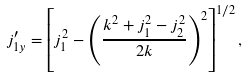<formula> <loc_0><loc_0><loc_500><loc_500>j ^ { \prime } _ { 1 y } = \left [ j _ { 1 } ^ { 2 } - \left ( \frac { k ^ { 2 } + j _ { 1 } ^ { 2 } - j _ { 2 } ^ { 2 } } { 2 k } \right ) ^ { 2 } \right ] ^ { 1 / 2 } ,</formula> 